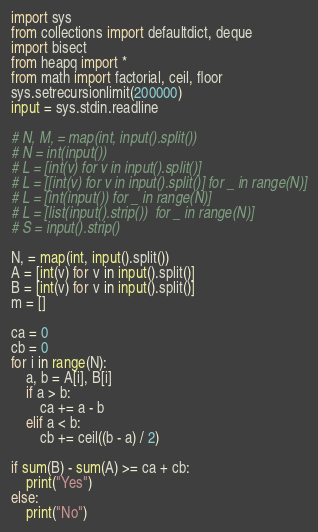<code> <loc_0><loc_0><loc_500><loc_500><_Python_>import sys
from collections import defaultdict, deque
import bisect
from heapq import *
from math import factorial, ceil, floor
sys.setrecursionlimit(200000)
input = sys.stdin.readline

# N, M, = map(int, input().split())
# N = int(input())
# L = [int(v) for v in input().split()]
# L = [[int(v) for v in input().split()] for _ in range(N)]
# L = [int(input()) for _ in range(N)]
# L = [list(input().strip())  for _ in range(N)]
# S = input().strip()

N, = map(int, input().split())
A = [int(v) for v in input().split()]
B = [int(v) for v in input().split()]
m = []

ca = 0
cb = 0
for i in range(N):
    a, b = A[i], B[i]
    if a > b:
        ca += a - b
    elif a < b:
        cb += ceil((b - a) / 2)

if sum(B) - sum(A) >= ca + cb:
    print("Yes")
else:
    print("No")</code> 